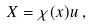<formula> <loc_0><loc_0><loc_500><loc_500>X = \chi ( x ) u \, ,</formula> 